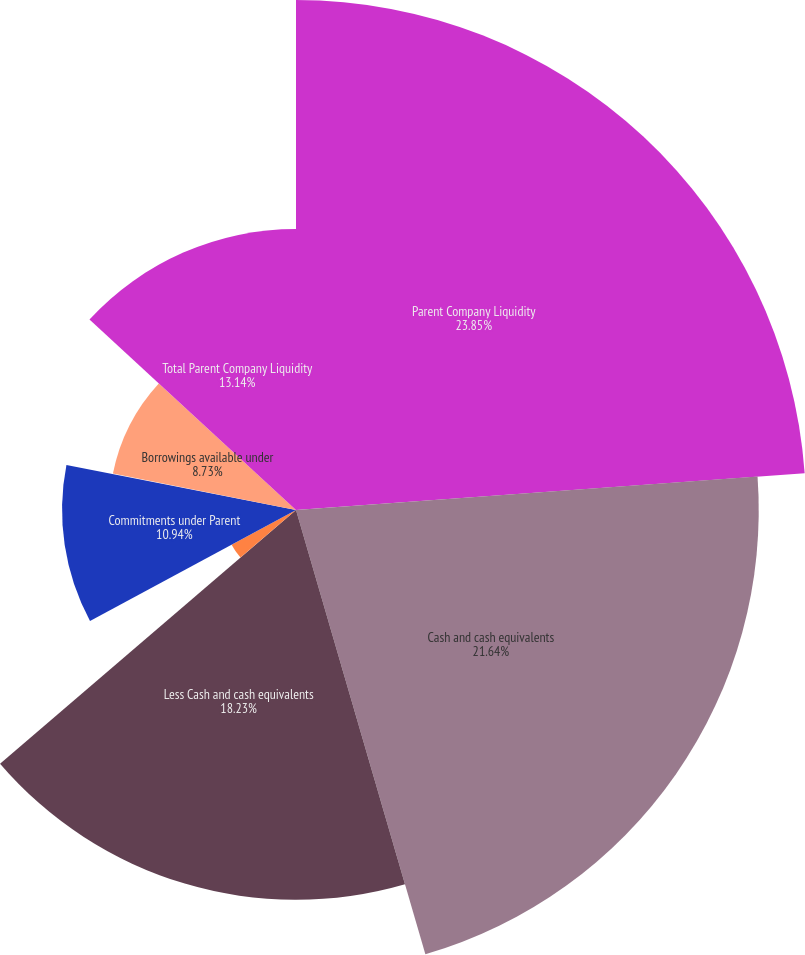Convert chart to OTSL. <chart><loc_0><loc_0><loc_500><loc_500><pie_chart><fcel>Parent Company Liquidity<fcel>Cash and cash equivalents<fcel>Less Cash and cash equivalents<fcel>Parent and qualified holding<fcel>Commitments under Parent<fcel>Less Letters of credit under<fcel>Borrowings available under<fcel>Total Parent Company Liquidity<nl><fcel>23.85%<fcel>21.64%<fcel>18.23%<fcel>3.42%<fcel>10.94%<fcel>0.05%<fcel>8.73%<fcel>13.14%<nl></chart> 